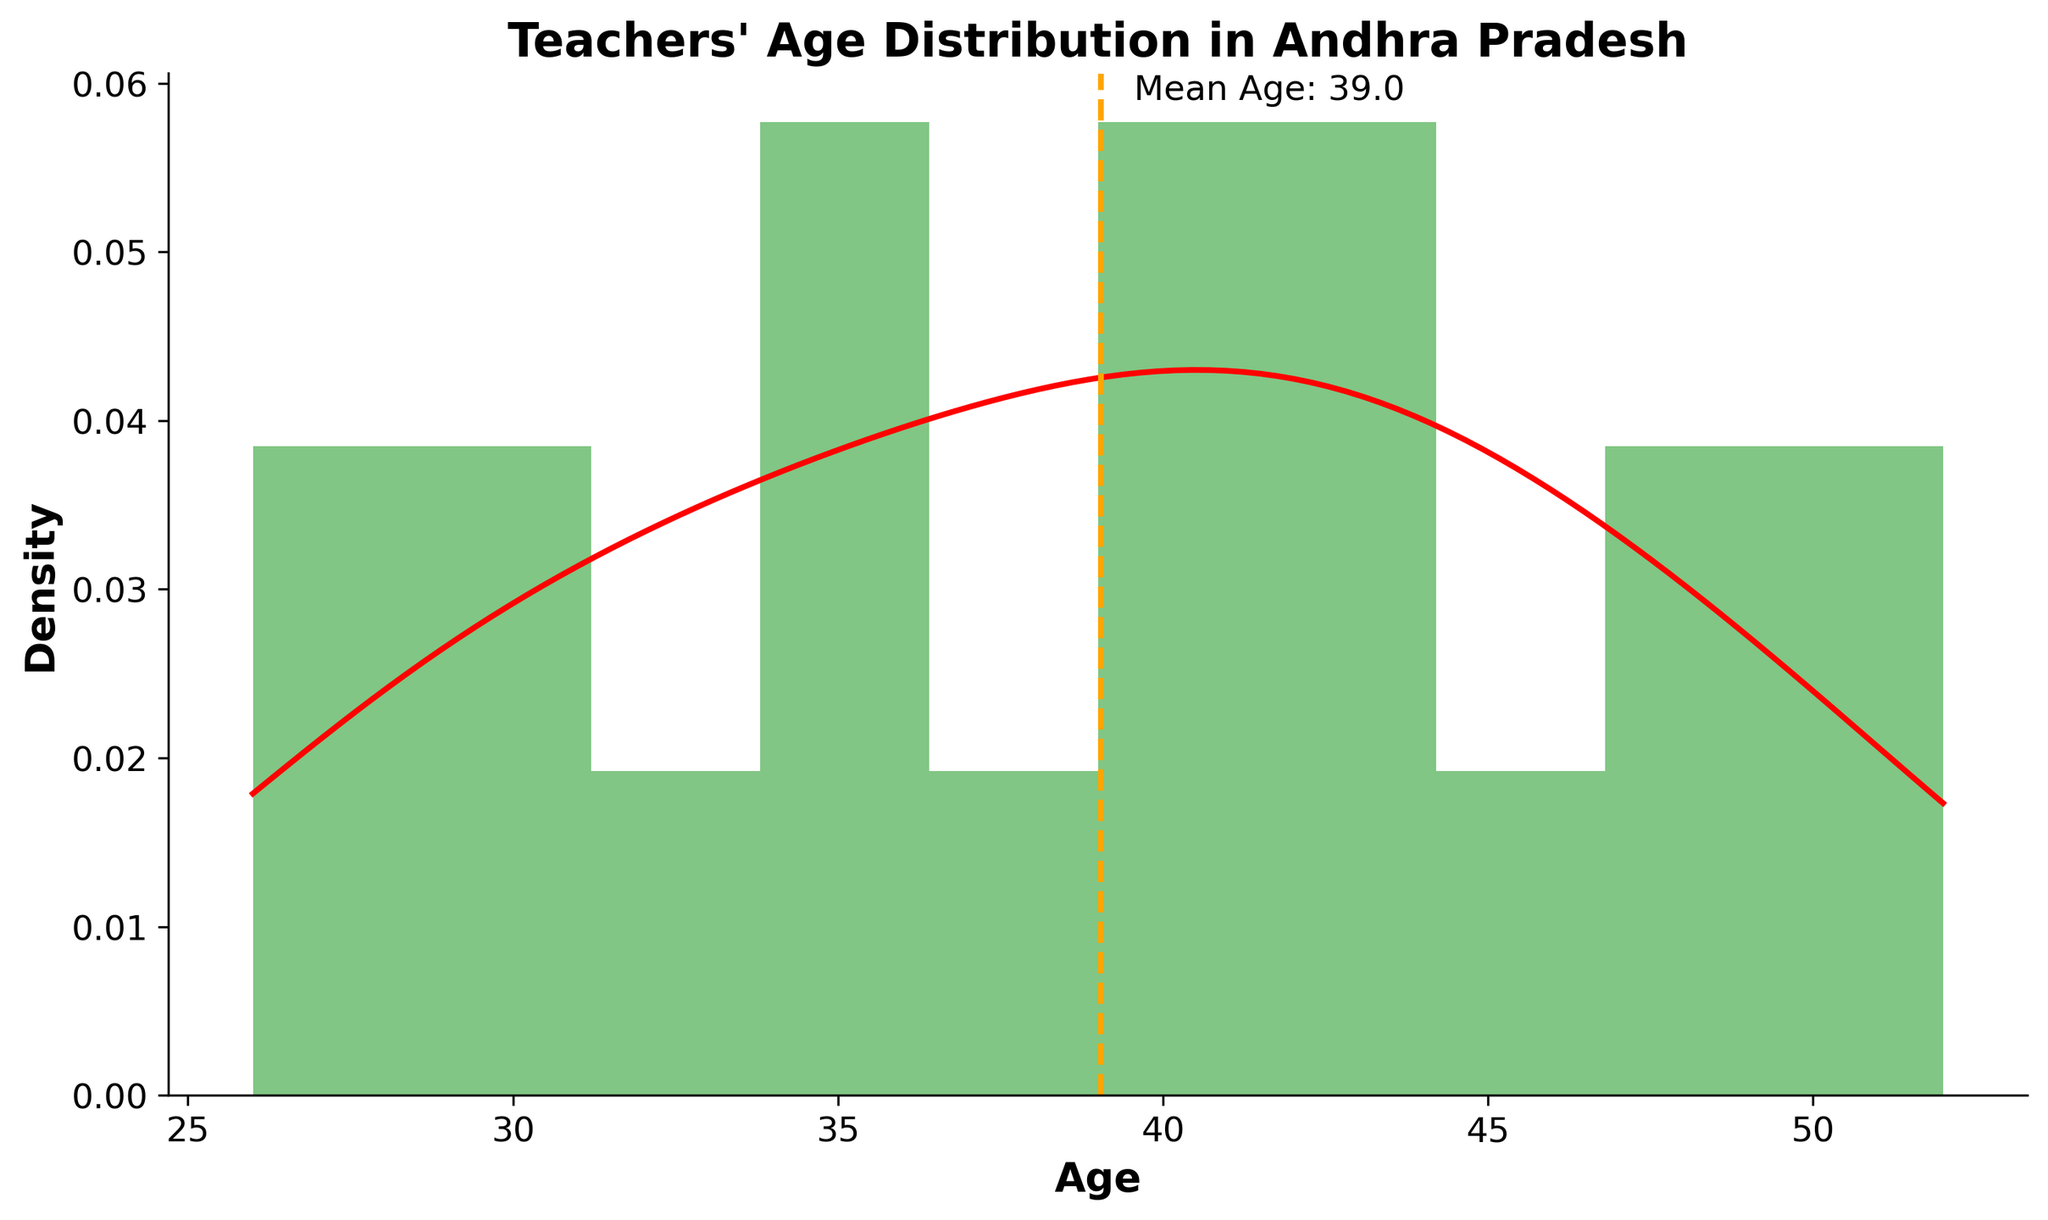How many age bins are used in the histogram? The histogram has 10 bins as defined in the code. You can see 10 segments on the x-axis indicating the age intervals grouped in each bin.
Answer: 10 What is the title of the distribution plot? The title of the plot is displayed at the top center and reads "Teachers' Age Distribution in Andhra Pradesh".
Answer: Teachers' Age Distribution in Andhra Pradesh What is the mean age of the teachers? The mean age is indicated by an orange dashed vertical line. The text near the line states 'Mean Age: 39.5'.
Answer: 39.5 Between which ages does the majority of the data lie? By looking at the histogram bars, you can see that most of the data lies between the ages 30 and 50, where the bars are the tallest.
Answer: 30 and 50 What does the red curve in the plot represent? The red curve is a Kernel Density Estimate (KDE) that shows the probability density function of the teachers' age distribution.
Answer: KDE of age distribution Which age group has the highest density in the plot? By observing the height of the bars and the KDE curve, it is clear that the age group around 40-45 shows the highest density.
Answer: 40-45 How does the number of teachers above the mean age compare to those below it? Visually compare the area under the histogram bars to the left and right of the mean age line. The bars are relatively symmetric, suggesting a roughly equal number of teachers above and below the mean age.
Answer: Roughly equal Is there any visible outlier in the age distribution? No specific bar or curve peak stands out drastically from the rest, implying no significant age outliers among the teachers.
Answer: No Does the distribution appear to be skewed? If so, in which direction? The distribution appears to be slightly right-skewed since the tail on the right side (toward older ages) is a bit longer than the left.
Answer: Slightly right-skewed What insights can you gain regarding the age range of teachers in the district? By examining the histogram and KDE, one can conclude most teachers are between 30-50 years old, with a mean age of 39.5, representing a seasoned workforce with a moderate level of experience.
Answer: Majority are 30-50 years old 